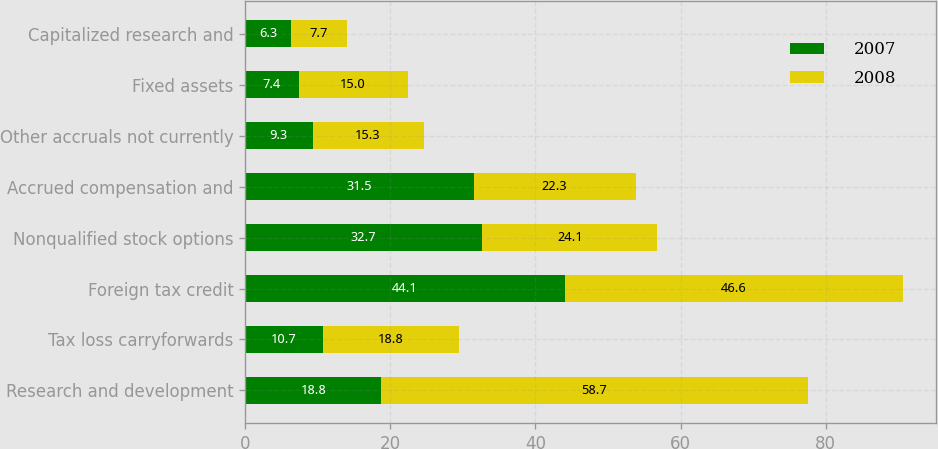Convert chart to OTSL. <chart><loc_0><loc_0><loc_500><loc_500><stacked_bar_chart><ecel><fcel>Research and development<fcel>Tax loss carryforwards<fcel>Foreign tax credit<fcel>Nonqualified stock options<fcel>Accrued compensation and<fcel>Other accruals not currently<fcel>Fixed assets<fcel>Capitalized research and<nl><fcel>2007<fcel>18.8<fcel>10.7<fcel>44.1<fcel>32.7<fcel>31.5<fcel>9.3<fcel>7.4<fcel>6.3<nl><fcel>2008<fcel>58.7<fcel>18.8<fcel>46.6<fcel>24.1<fcel>22.3<fcel>15.3<fcel>15<fcel>7.7<nl></chart> 